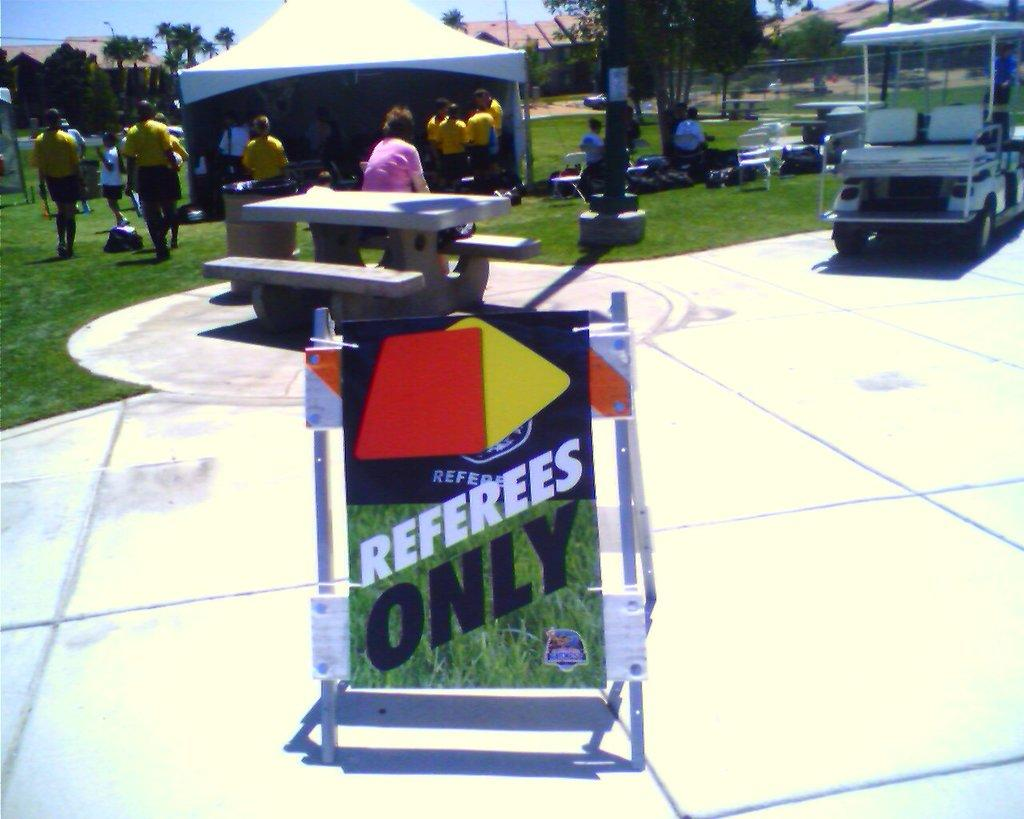<image>
Offer a succinct explanation of the picture presented. Sign outdoors on the ground that says "Referees only". 